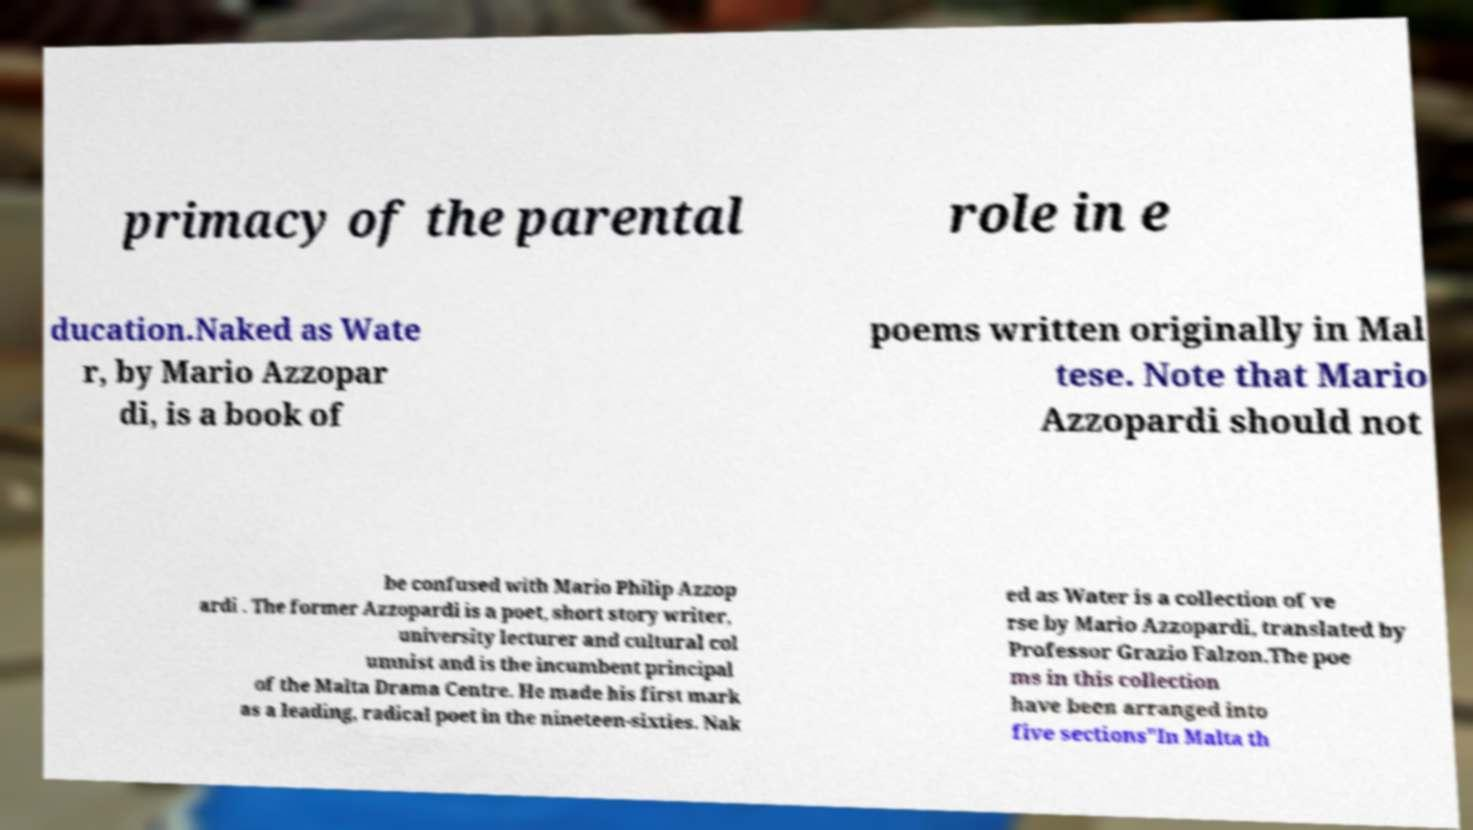Can you accurately transcribe the text from the provided image for me? primacy of the parental role in e ducation.Naked as Wate r, by Mario Azzopar di, is a book of poems written originally in Mal tese. Note that Mario Azzopardi should not be confused with Mario Philip Azzop ardi . The former Azzopardi is a poet, short story writer, university lecturer and cultural col umnist and is the incumbent principal of the Malta Drama Centre. He made his first mark as a leading, radical poet in the nineteen-sixties. Nak ed as Water is a collection of ve rse by Mario Azzopardi, translated by Professor Grazio Falzon.The poe ms in this collection have been arranged into five sections"In Malta th 